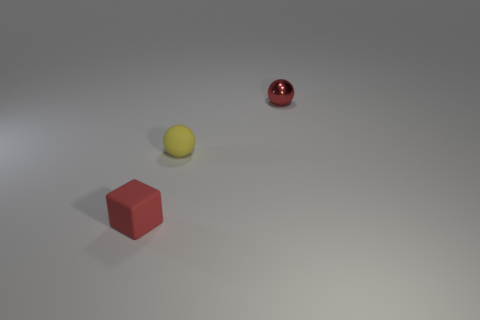Add 3 big blue metal balls. How many objects exist? 6 Subtract all blocks. How many objects are left? 2 Subtract 1 red cubes. How many objects are left? 2 Subtract all small yellow balls. Subtract all small gray matte cylinders. How many objects are left? 2 Add 2 shiny objects. How many shiny objects are left? 3 Add 3 spheres. How many spheres exist? 5 